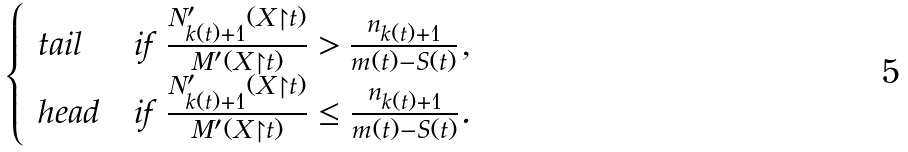<formula> <loc_0><loc_0><loc_500><loc_500>\begin{cases} \ t a i l & \text {if $\frac{N_{k(t)+1}^{\prime}(X\restriction t)}{M^{\prime}(X\restriction t)}>\frac{n_{k(t)+1}}{m(t)-S(t)}$,} \\ \ h e a d & \text {if $\frac{N_{k(t)+1}^{\prime}(X\restriction t)}{M^{\prime}(X\restriction t)}\leq\frac{n_{k(t)+1}}{m(t)-S(t)}$.} \end{cases}</formula> 